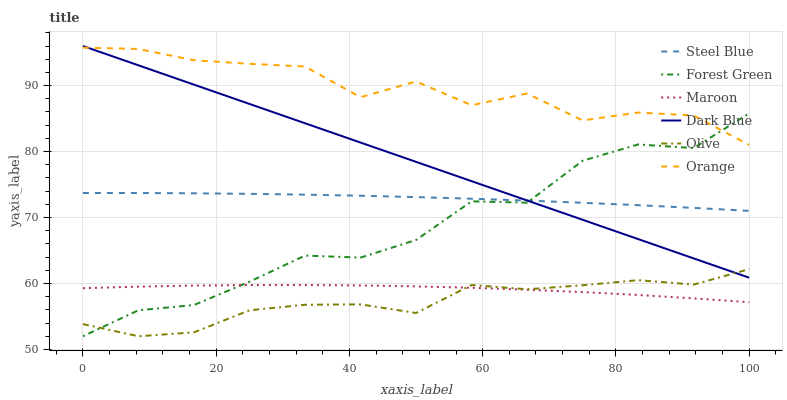Does Olive have the minimum area under the curve?
Answer yes or no. Yes. Does Orange have the maximum area under the curve?
Answer yes or no. Yes. Does Maroon have the minimum area under the curve?
Answer yes or no. No. Does Maroon have the maximum area under the curve?
Answer yes or no. No. Is Dark Blue the smoothest?
Answer yes or no. Yes. Is Orange the roughest?
Answer yes or no. Yes. Is Maroon the smoothest?
Answer yes or no. No. Is Maroon the roughest?
Answer yes or no. No. Does Forest Green have the lowest value?
Answer yes or no. Yes. Does Maroon have the lowest value?
Answer yes or no. No. Does Dark Blue have the highest value?
Answer yes or no. Yes. Does Maroon have the highest value?
Answer yes or no. No. Is Steel Blue less than Orange?
Answer yes or no. Yes. Is Orange greater than Maroon?
Answer yes or no. Yes. Does Orange intersect Dark Blue?
Answer yes or no. Yes. Is Orange less than Dark Blue?
Answer yes or no. No. Is Orange greater than Dark Blue?
Answer yes or no. No. Does Steel Blue intersect Orange?
Answer yes or no. No. 